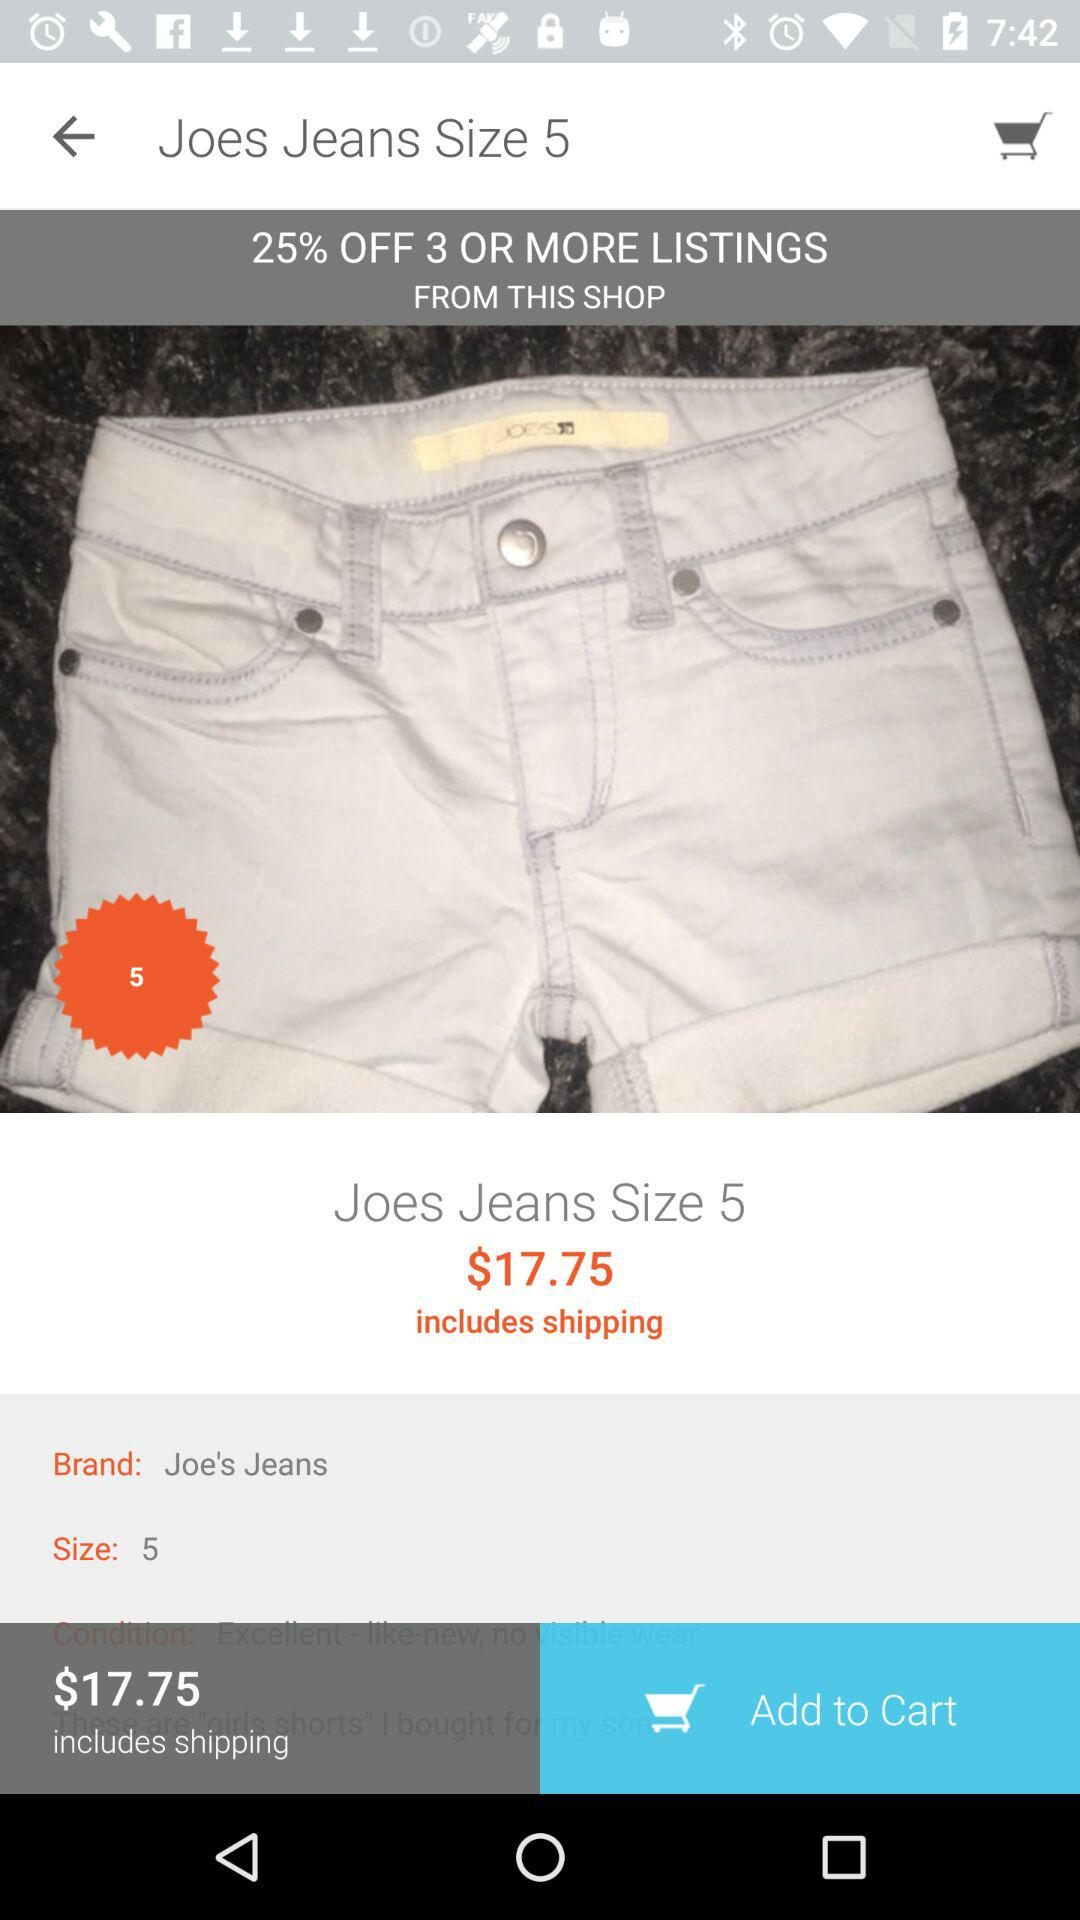What is the brand of jeans? The brand is Joe's Jeans. 